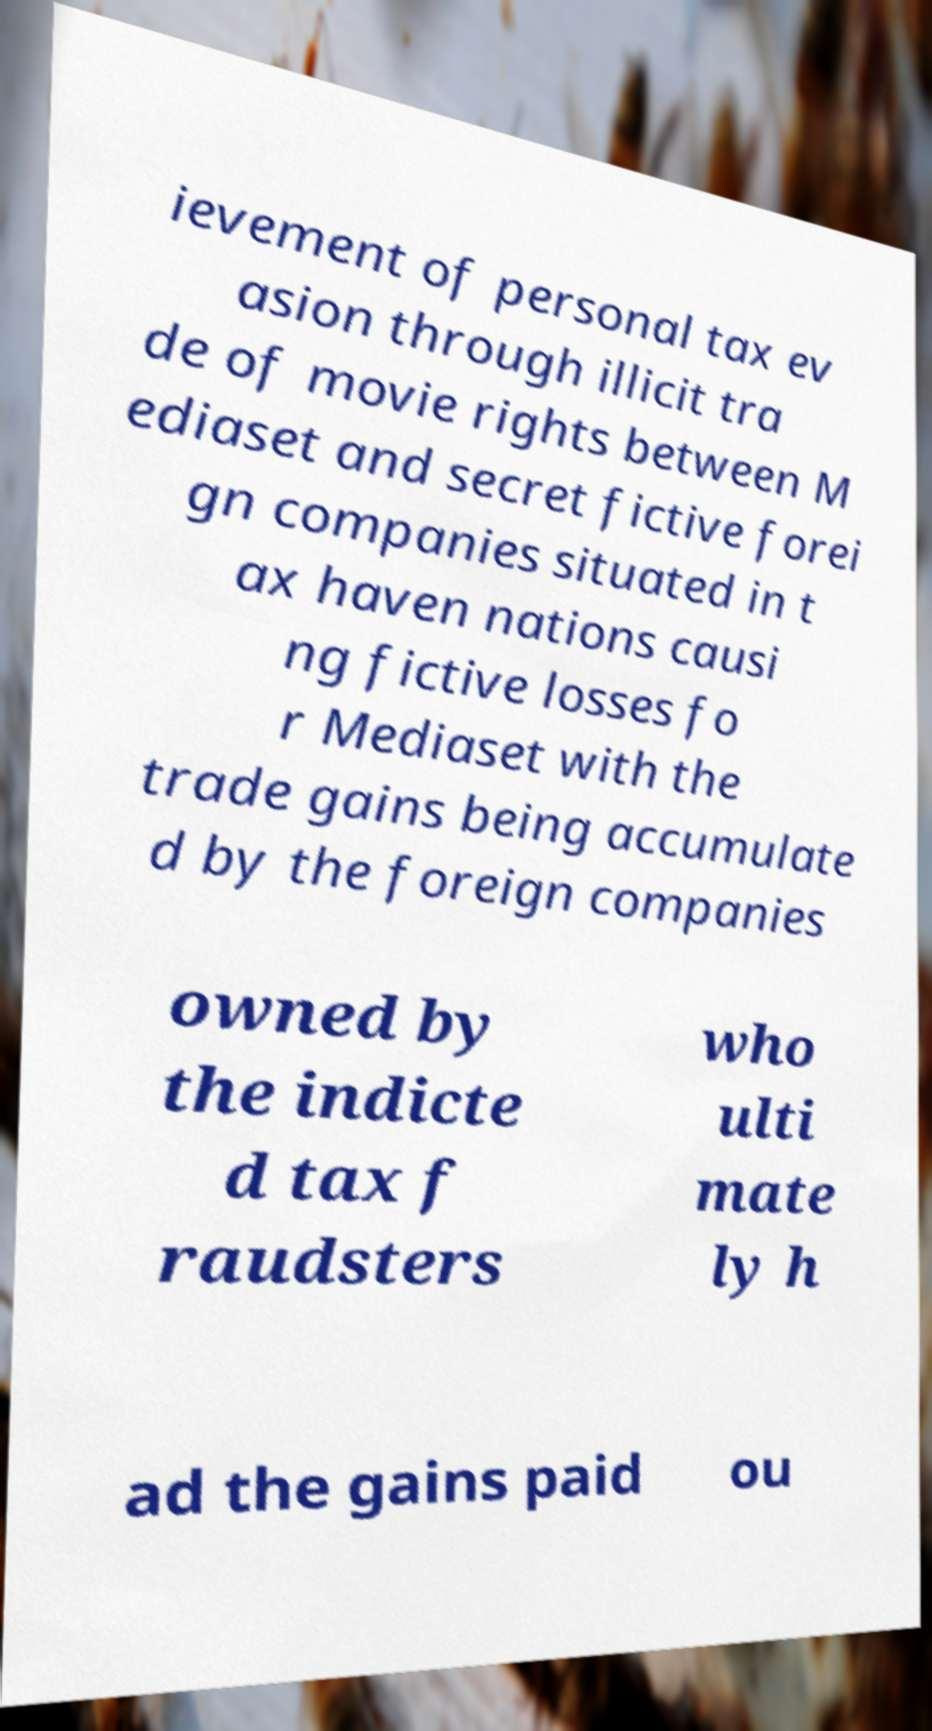What messages or text are displayed in this image? I need them in a readable, typed format. ievement of personal tax ev asion through illicit tra de of movie rights between M ediaset and secret fictive forei gn companies situated in t ax haven nations causi ng fictive losses fo r Mediaset with the trade gains being accumulate d by the foreign companies owned by the indicte d tax f raudsters who ulti mate ly h ad the gains paid ou 